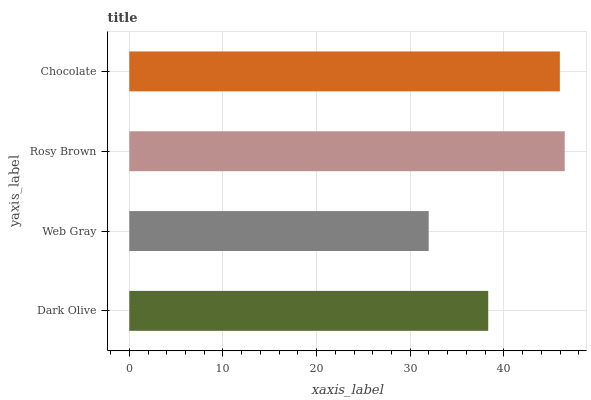Is Web Gray the minimum?
Answer yes or no. Yes. Is Rosy Brown the maximum?
Answer yes or no. Yes. Is Rosy Brown the minimum?
Answer yes or no. No. Is Web Gray the maximum?
Answer yes or no. No. Is Rosy Brown greater than Web Gray?
Answer yes or no. Yes. Is Web Gray less than Rosy Brown?
Answer yes or no. Yes. Is Web Gray greater than Rosy Brown?
Answer yes or no. No. Is Rosy Brown less than Web Gray?
Answer yes or no. No. Is Chocolate the high median?
Answer yes or no. Yes. Is Dark Olive the low median?
Answer yes or no. Yes. Is Web Gray the high median?
Answer yes or no. No. Is Chocolate the low median?
Answer yes or no. No. 